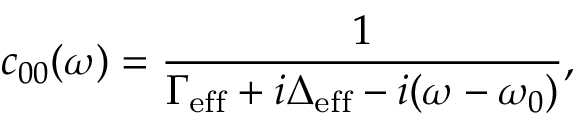<formula> <loc_0><loc_0><loc_500><loc_500>c _ { 0 0 } ( \omega ) = \frac { 1 } { \Gamma _ { e f f } + i \Delta _ { e f f } - i ( \omega - \omega _ { 0 } ) } ,</formula> 